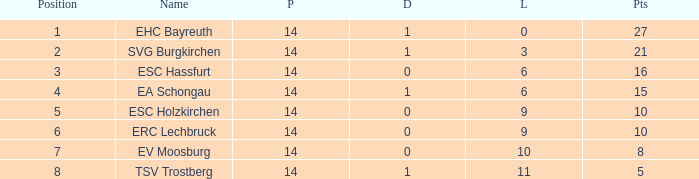What's the points that has a lost more 6, played less than 14 and a position more than 1? None. 